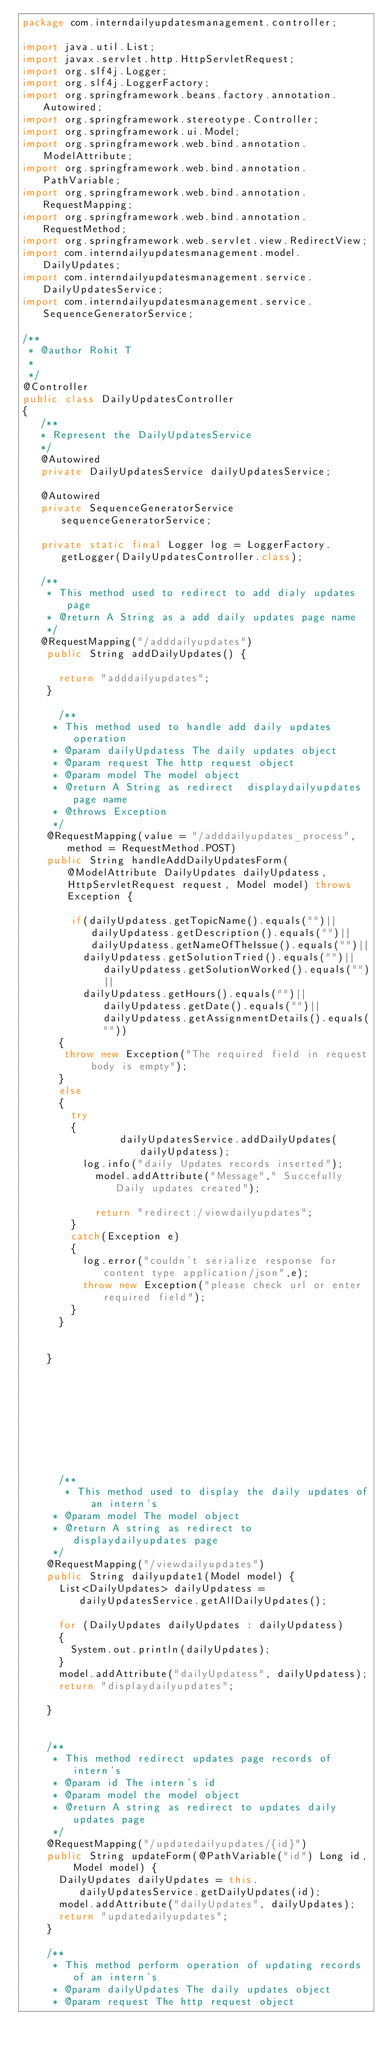Convert code to text. <code><loc_0><loc_0><loc_500><loc_500><_Java_>package com.interndailyupdatesmanagement.controller;

import java.util.List;
import javax.servlet.http.HttpServletRequest;
import org.slf4j.Logger;
import org.slf4j.LoggerFactory;
import org.springframework.beans.factory.annotation.Autowired;
import org.springframework.stereotype.Controller;
import org.springframework.ui.Model;
import org.springframework.web.bind.annotation.ModelAttribute;
import org.springframework.web.bind.annotation.PathVariable;
import org.springframework.web.bind.annotation.RequestMapping;
import org.springframework.web.bind.annotation.RequestMethod;
import org.springframework.web.servlet.view.RedirectView;
import com.interndailyupdatesmanagement.model.DailyUpdates;
import com.interndailyupdatesmanagement.service.DailyUpdatesService;
import com.interndailyupdatesmanagement.service.SequenceGeneratorService;

/**
 * @author Rohit T
 *
 */
@Controller
public class DailyUpdatesController 
{
   /**
   * Represent the DailyUpdatesService
   */
   @Autowired
   private DailyUpdatesService dailyUpdatesService;

   @Autowired
   private SequenceGeneratorService sequenceGeneratorService;
   
   private static final Logger log = LoggerFactory.getLogger(DailyUpdatesController.class);

   /**
    * This method used to redirect to add dialy updates page
    * @return A String as a add daily updates page name
    */
   @RequestMapping("/adddailyupdates")
  	public String addDailyUpdates() {

  		return "adddailyupdates";
  	}
      
      /**
     * This method used to handle add daily updates operation
     * @param dailyUpdatess The daily updates object
     * @param request The http request object
     * @param model The model object
     * @return A String as redirect  displaydailyupdates page name
     * @throws Exception 
     */
    @RequestMapping(value = "/adddailyupdates_process", method = RequestMethod.POST)
  	public String handleAddDailyUpdatesForm(@ModelAttribute DailyUpdates dailyUpdatess, HttpServletRequest request, Model model) throws Exception {

    	  if(dailyUpdatess.getTopicName().equals("")||dailyUpdatess.getDescription().equals("")|| dailyUpdatess.getNameOfTheIssue().equals("")||
  				dailyUpdatess.getSolutionTried().equals("")||dailyUpdatess.getSolutionWorked().equals("")||
  				dailyUpdatess.getHours().equals("")||dailyUpdatess.getDate().equals("")||dailyUpdatess.getAssignmentDetails().equals(""))
  		{
  		 throw new Exception("The required field in request body is empty");
  		}
  		else
  		{
  			try
  			{
  	            dailyUpdatesService.addDailyUpdates(dailyUpdatess);
  				log.info("daily Updates records inserted");
  		  		model.addAttribute("Message"," Succefully Daily updates created");
  		  		
  		  		return "redirect:/viewdailyupdates";
  			}
  			catch(Exception e)
  			{
  				log.error("couldn't serialize response for content type application/json",e);
  				throw new Exception("please check url or enter required field");
  			}
  		}


  	}
      
      
      
      
      
      
      
      
      
      /**
       * This method used to display the daily updates of an intern's
     * @param model The model object
     * @return A string as redirect to displaydailyupdates page
     */
    @RequestMapping("/viewdailyupdates")
  	public String dailyupdate1(Model model) {
  		List<DailyUpdates> dailyUpdatess = dailyUpdatesService.getAllDailyUpdates();

  		for (DailyUpdates dailyUpdates : dailyUpdatess)
  		{
  			System.out.println(dailyUpdates);
  		}
  		model.addAttribute("dailyUpdatess", dailyUpdatess);
  		return "displaydailyupdates";

  	}
      
    
 		/**
 		 * This method redirect updates page records of intern's
 		 * @param id The intern's id
 		 * @param model the model object
 		 * @return A string as redirect to updates daily updates page
 		 */
 		@RequestMapping("/updatedailyupdates/{id}")
 		public String updateForm(@PathVariable("id") Long id, Model model) {
 			DailyUpdates dailyUpdates = this.dailyUpdatesService.getDailyUpdates(id);
 			model.addAttribute("dailyUpdates", dailyUpdates);
 			return "updatedailyupdates";
 		}

 		/**
 		 * This method perform operation of updating records of an intern's
 		 * @param dailyUpdates The daily updates object
 		 * @param request The http request object</code> 